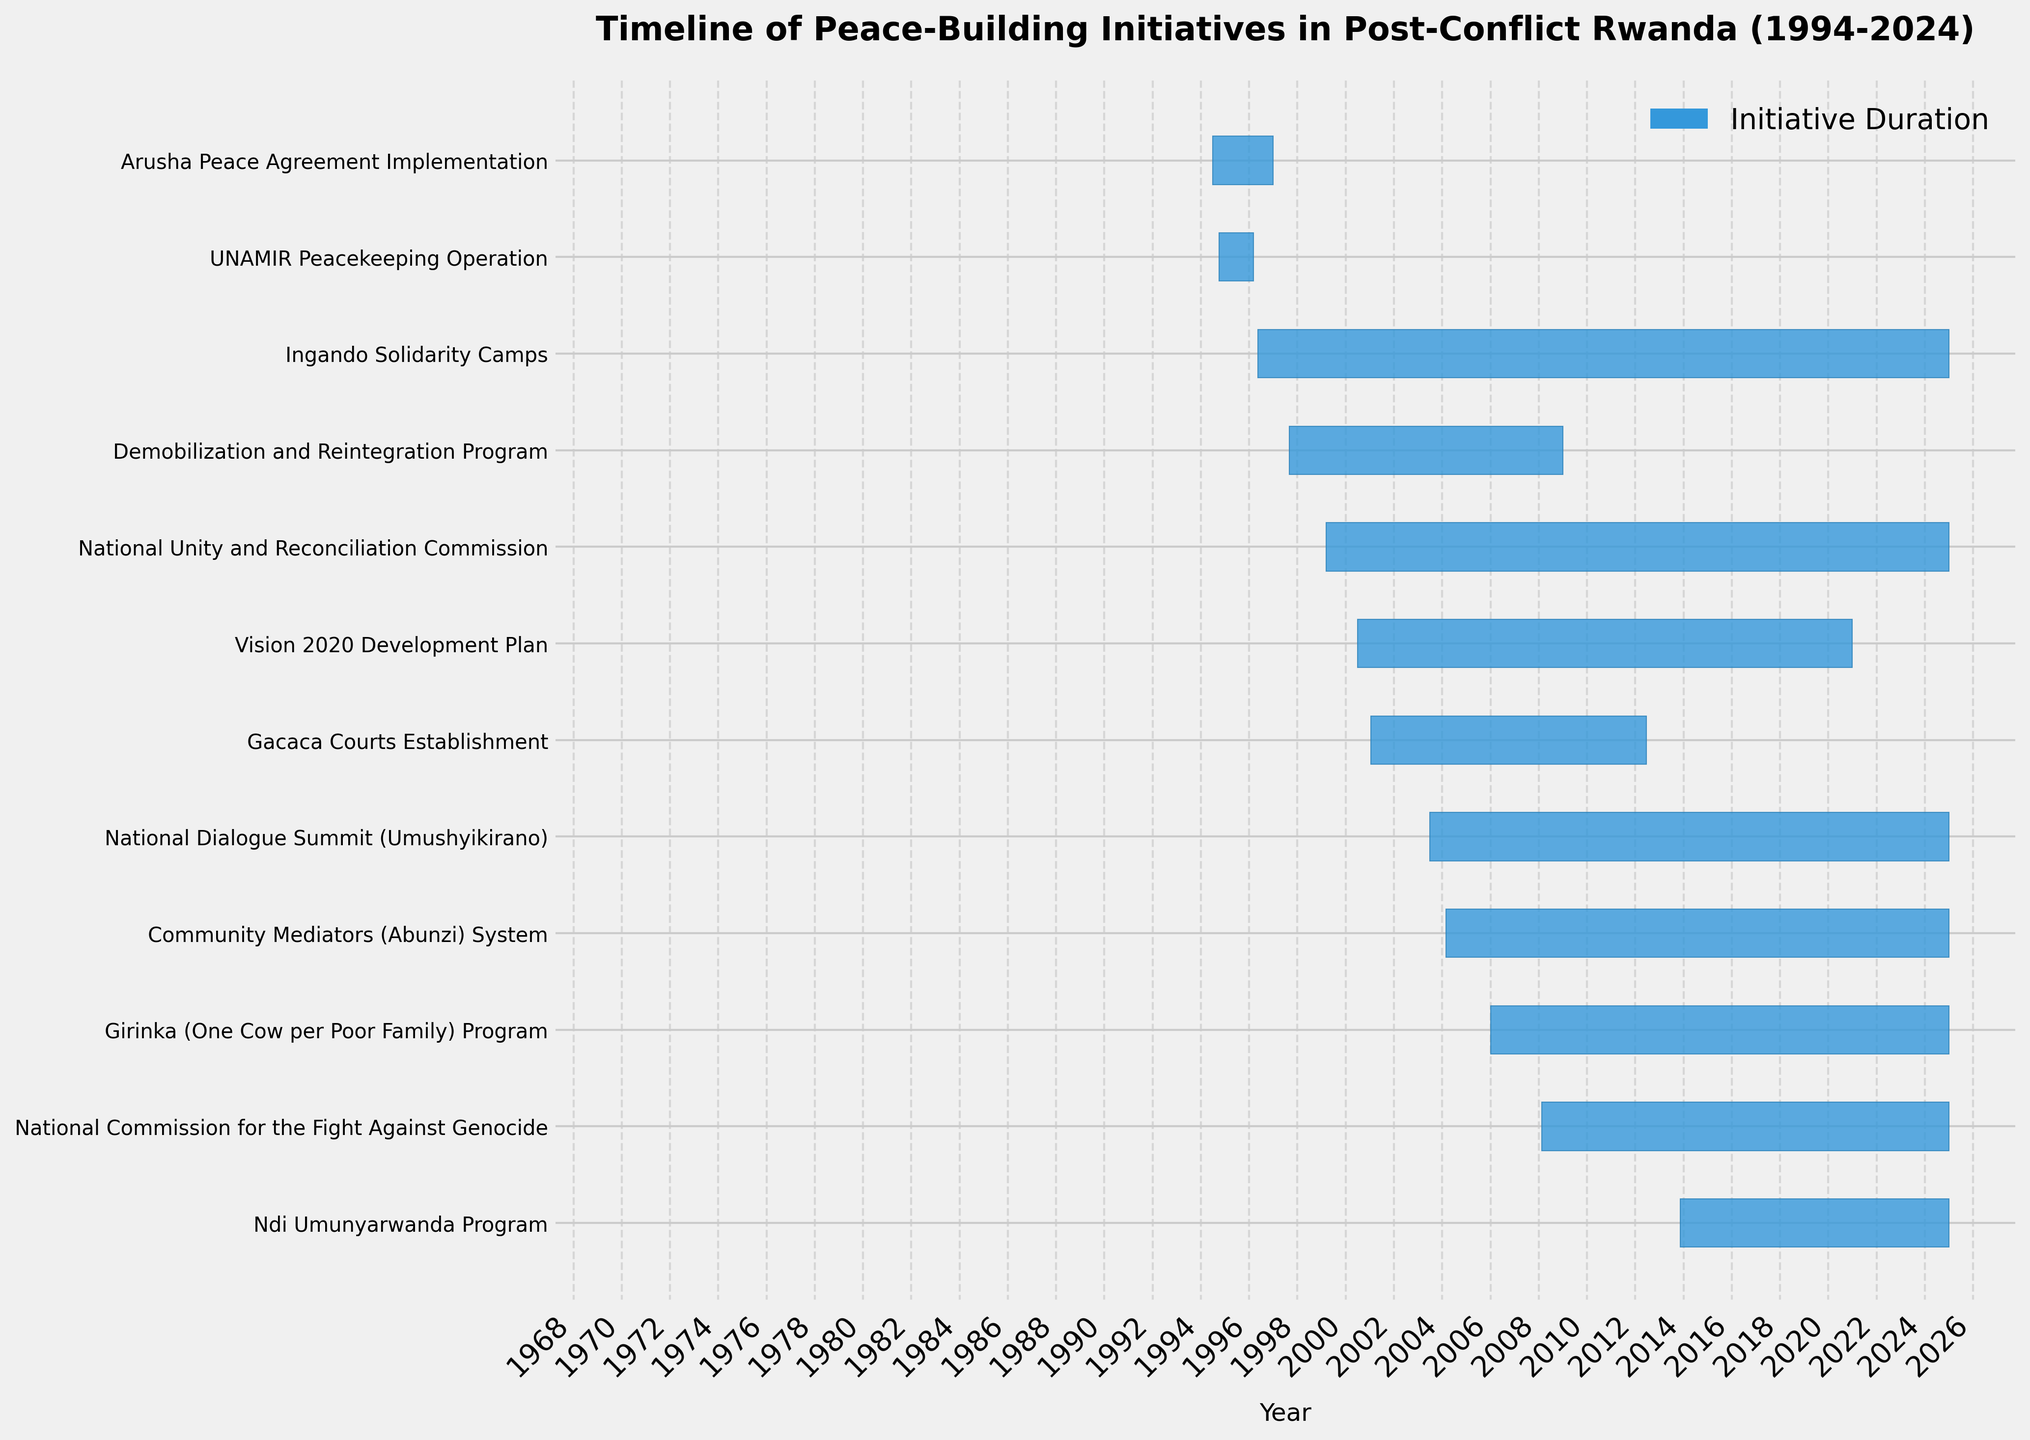What is the title of the Gantt chart? The title of the Gantt chart is located at the top of the figure. By reading this part, we can see the designated title of the chart.
Answer: Timeline of Peace-Building Initiatives in Post-Conflict Rwanda (1994-2024) How many initiatives are scheduled to last until 2024? To find the number of initiatives lasting until 2024, we check how many bars extend to the end of the x-axis, representing the year 2024.
Answer: 8 Which initiative started first, Arusha Peace Agreement Implementation or Ingando Solidarity Camps? By comparing the starting dates on the y-axis for both Arusha Peace Agreement Implementation and Ingando Solidarity Camps, we can determine which one started first based on their positions.
Answer: Arusha Peace Agreement Implementation How long was the Vision 2020 Development Plan active? Referring to the bar length for Vision 2020 Development Plan, we can determine the active duration. The Gantt chart shows start and end dates to calculate the duration.
Answer: 20 years Which initiative had the longest duration, and how long was it? The longest bar on the chart represents the initiative with the longest duration. By measuring its length against the x-axis, we can identify its total duration.
Answer: National Unity and Reconciliation Commission, 26 years How many peace-building initiatives commenced before the year 2000? To determine the number of initiatives that commenced before 2000, we examine the starting points of each bar on the x-axis and count those before the year 2000.
Answer: 6 Which initiative ended first, UNAMIR Peacekeeping Operation or Arusha Peace Agreement Implementation? By comparing the ending points of the respective bars on the x-axis, we can see that UNAMIR Peacekeeping Operation and Arusha Peace Agreement Implementation concluded.
Answer: UNAMIR Peacekeeping Operation Compare the durations of the Gacaca Courts Establishment and the Demobilization and Reintegration Program. Which one was longer and by how many years? By checking the bar lengths for Gacaca Courts Establishment and Demobilization and Reintegration Program on the x-axis, we can identify and compare their durations.
Answer: Gacaca Courts Establishment, by 4.5 years List all initiatives that started in the year 2006 or later. To find initiatives that started in 2006 or later, we examine the start points from the year 2006 onwards on the x-axis and list them accordingly.
Answer: Girinka (One Cow per Poor Family) Program, Ndi Umunyarwanda Program, National Commission for the Fight Against Genocide What is the overlap duration between the National Dialogue Summit (Umushyikirano) and Ndi Umunyarwanda Program? To find the overlap duration, we compare the start and end dates of both initiatives and calculate the common time period.
Answer: 11 years 